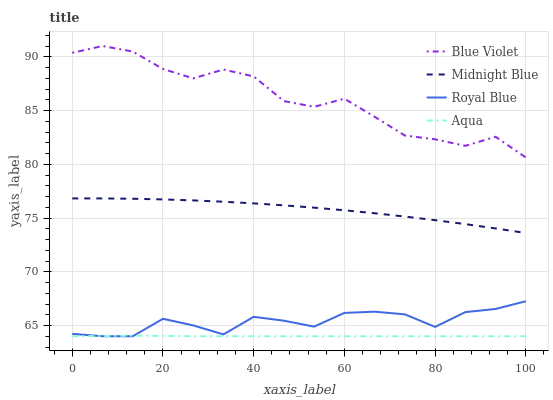Does Aqua have the minimum area under the curve?
Answer yes or no. Yes. Does Blue Violet have the maximum area under the curve?
Answer yes or no. Yes. Does Midnight Blue have the minimum area under the curve?
Answer yes or no. No. Does Midnight Blue have the maximum area under the curve?
Answer yes or no. No. Is Aqua the smoothest?
Answer yes or no. Yes. Is Blue Violet the roughest?
Answer yes or no. Yes. Is Midnight Blue the smoothest?
Answer yes or no. No. Is Midnight Blue the roughest?
Answer yes or no. No. Does Royal Blue have the lowest value?
Answer yes or no. Yes. Does Midnight Blue have the lowest value?
Answer yes or no. No. Does Blue Violet have the highest value?
Answer yes or no. Yes. Does Midnight Blue have the highest value?
Answer yes or no. No. Is Royal Blue less than Blue Violet?
Answer yes or no. Yes. Is Blue Violet greater than Royal Blue?
Answer yes or no. Yes. Does Royal Blue intersect Aqua?
Answer yes or no. Yes. Is Royal Blue less than Aqua?
Answer yes or no. No. Is Royal Blue greater than Aqua?
Answer yes or no. No. Does Royal Blue intersect Blue Violet?
Answer yes or no. No. 